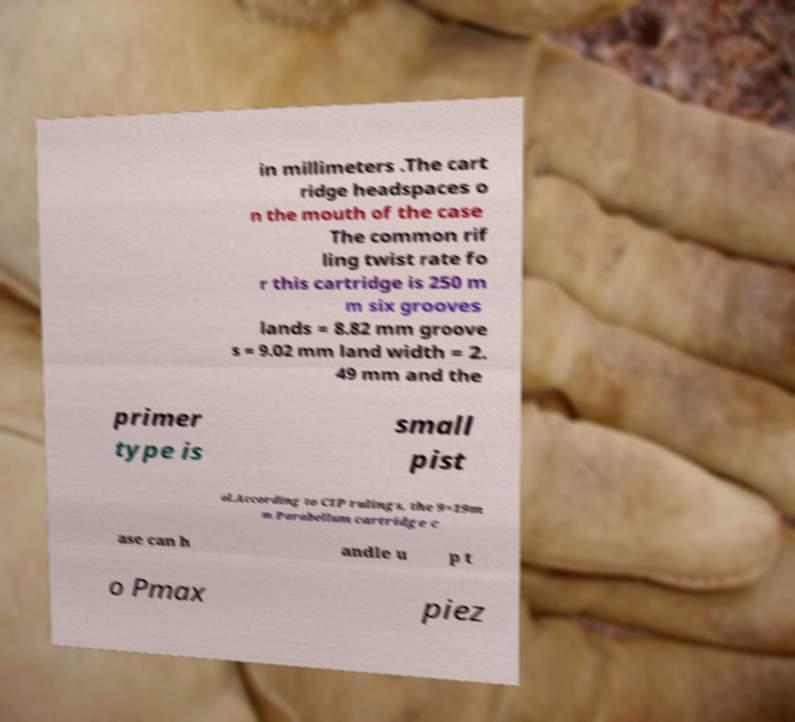Can you read and provide the text displayed in the image?This photo seems to have some interesting text. Can you extract and type it out for me? in millimeters .The cart ridge headspaces o n the mouth of the case The common rif ling twist rate fo r this cartridge is 250 m m six grooves lands = 8.82 mm groove s = 9.02 mm land width = 2. 49 mm and the primer type is small pist ol.According to CIP rulings, the 9×19m m Parabellum cartridge c ase can h andle u p t o Pmax piez 